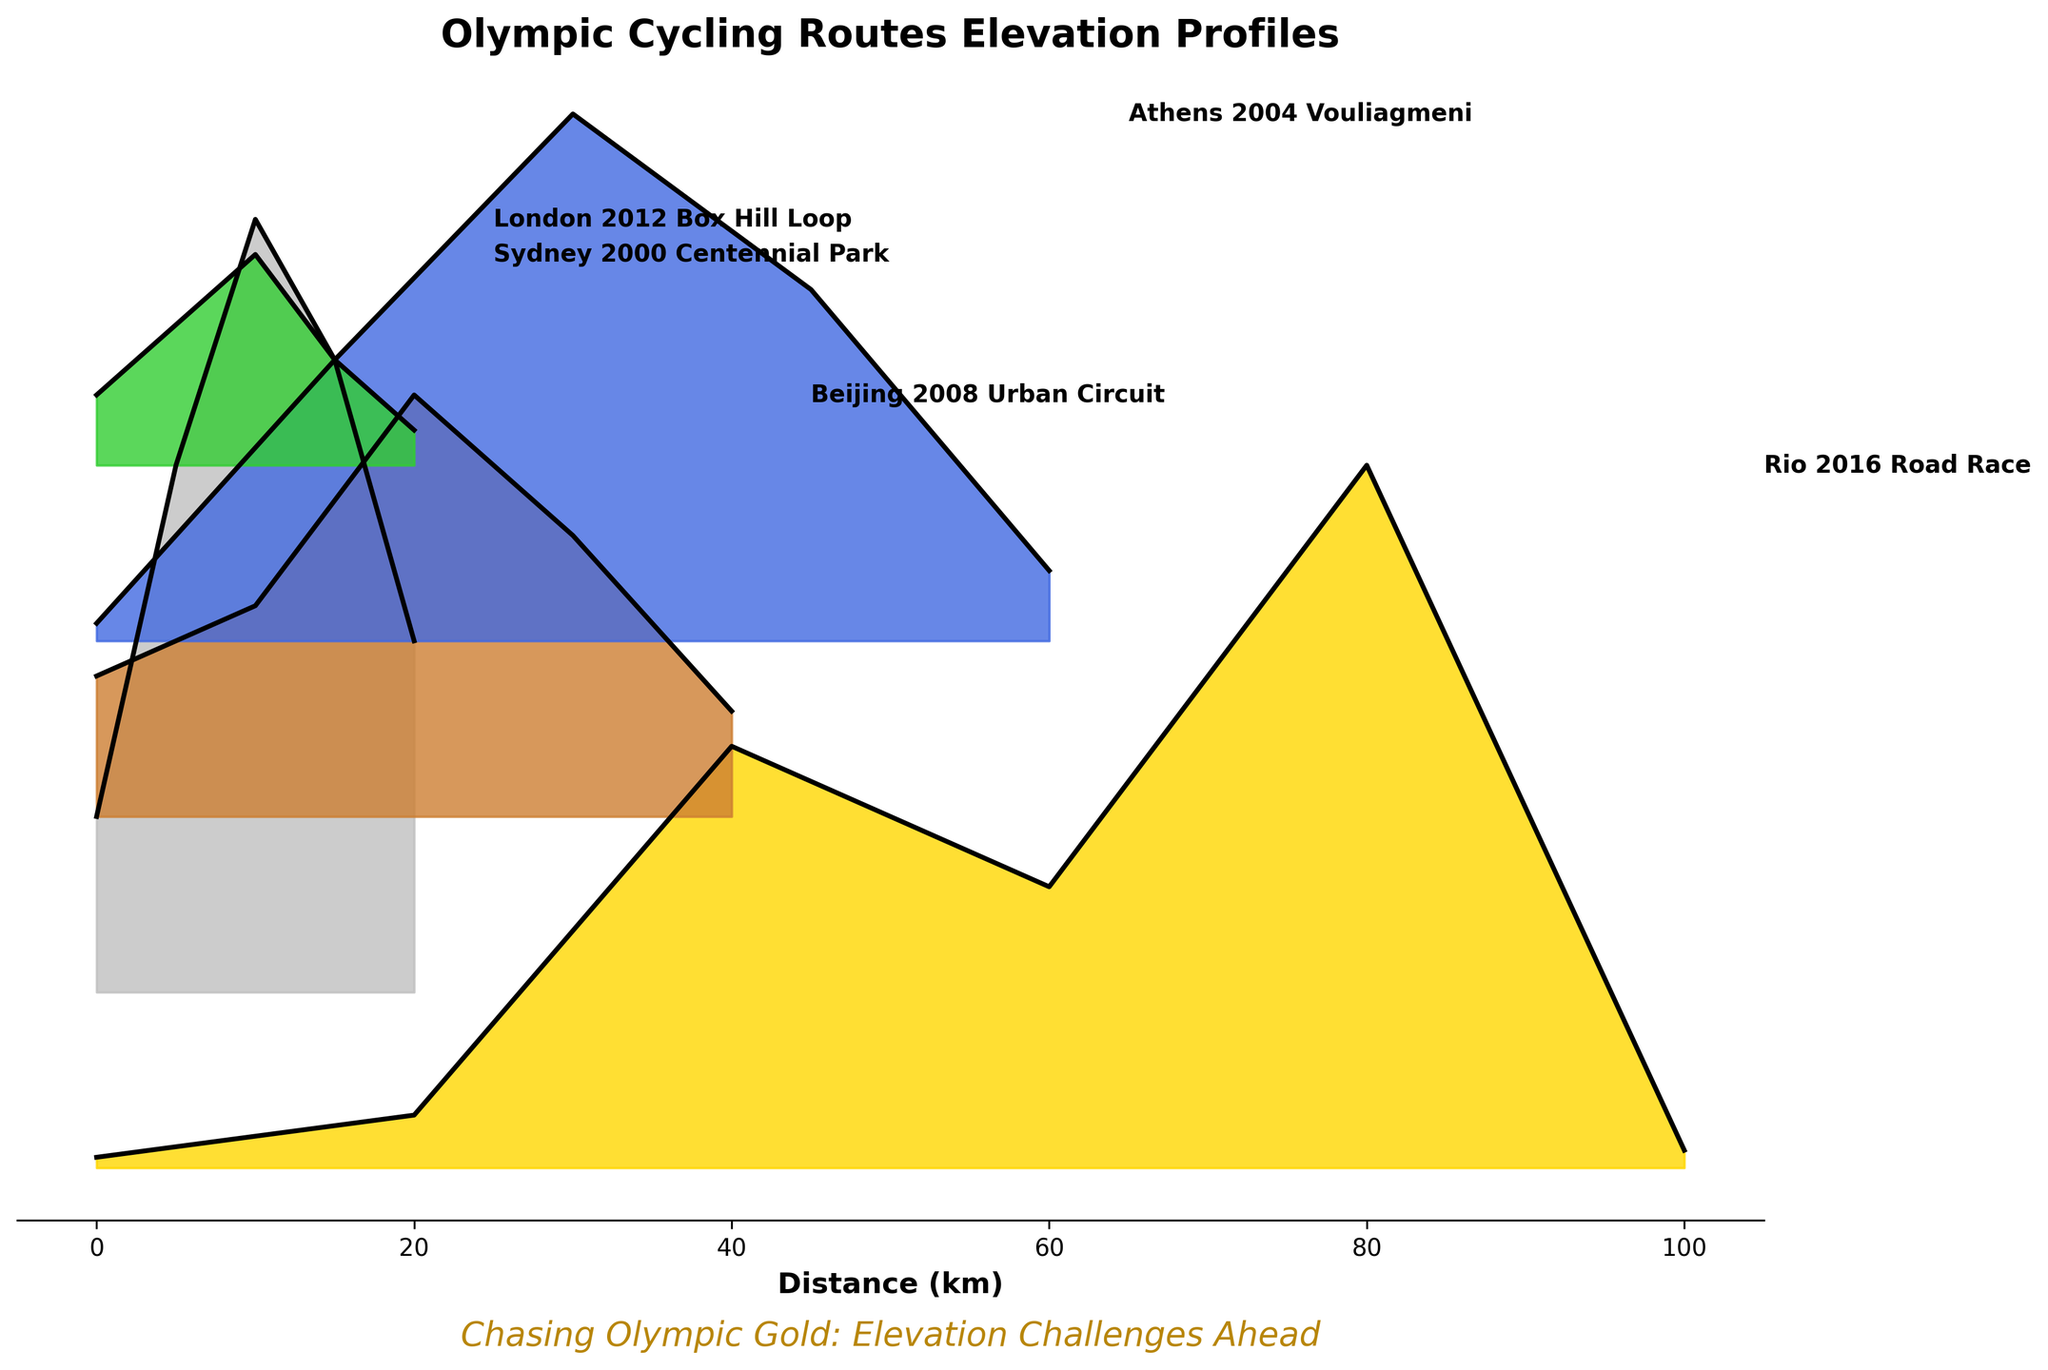What is the title of the plot? The title is usually located at the top center of a plot. In this case, it reads "Olympic Cycling Routes Elevation Profiles".
Answer: Olympic Cycling Routes Elevation Profiles How many routes are shown in the plot? Counting each unique label or section on the y-axis or within the filled areas reveals the number of routes. There are five routes in total.
Answer: 5 What is the maximum elevation reached in the Rio 2016 Road Race? By following the Rio 2016 Road Race line and identifying the highest peak reached on the elevation axis, the maximum elevation is found to be 200m.
Answer: 200m Which route has the highest initial elevation? By looking at the start (0km) of each route on the x-axis and comparing elevations on the y-axis, the London 2012 Box Hill Loop starts at the highest elevation of 50m.
Answer: London 2012 Box Hill Loop Which route has the least elevation change over its course? Comparing the difference in elevation from the start to finish for each route shows that the Sydney 2000 Centennial Park route has the least change, starting and ending near 20m and 10m respectively.
Answer: Sydney 2000 Centennial Park How do the maximum elevations of the Rio 2016 Road Race and the London 2012 Box Hill Loop compare? The Rio 2016 Road Race and the London 2012 Box Hill Loop have maximum elevations of 200m and 220m respectively, making the London 2012 slightly higher.
Answer: London 2012 Box Hill Loop What can be observed about the elevation of Athens 2004 Vouliagmeni at mid-point (around 30km)? Examining the middle section (30km) of the Athens 2004 Vouliagmeni route, the elevation peaks around 150m.
Answer: 150m If you sum the maximum elevations of all routes, what is the total? Adding the maximum elevations: Rio 2016 (200m) + London 2012 (220m) + Beijing 2008 (120m) + Athens 2004 (150m) + Sydney 2000 (60m) equals 750m.
Answer: 750m Which route shows the steepest initial climb in elevation? Observing the elevation change from 0km to around 5km, the London 2012 Box Hill Loop shows the steepest climb, rising by 100m (50m to 150m).
Answer: London 2012 Box Hill Loop 